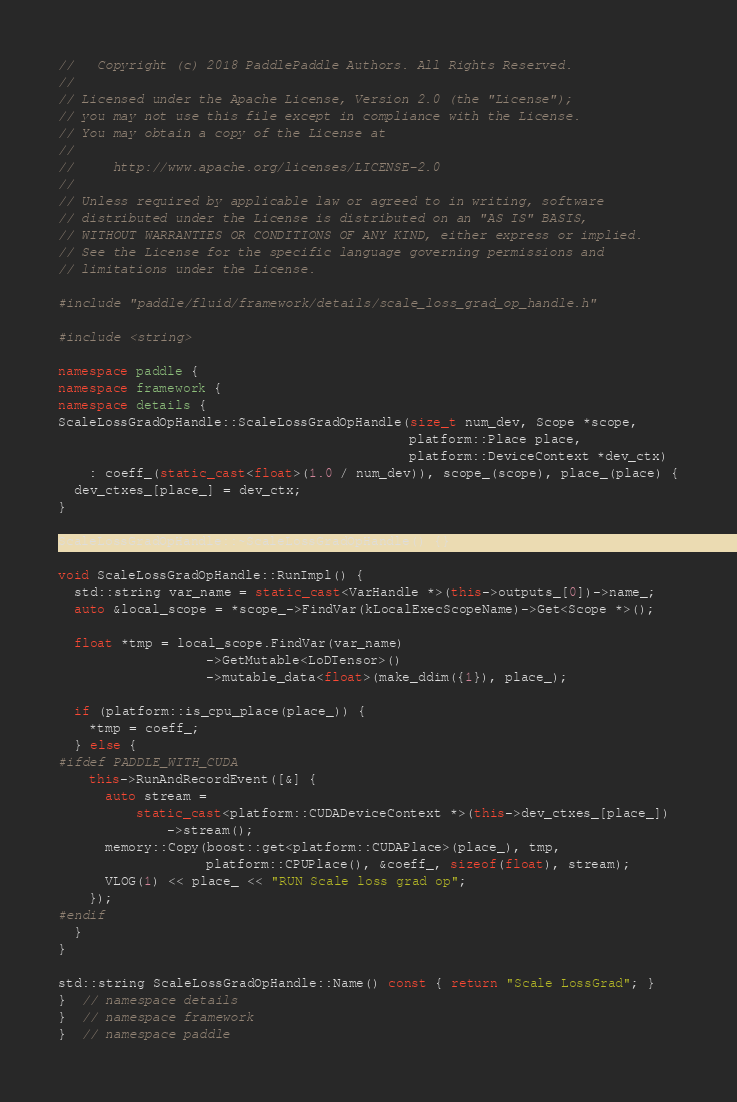<code> <loc_0><loc_0><loc_500><loc_500><_C++_>//   Copyright (c) 2018 PaddlePaddle Authors. All Rights Reserved.
//
// Licensed under the Apache License, Version 2.0 (the "License");
// you may not use this file except in compliance with the License.
// You may obtain a copy of the License at
//
//     http://www.apache.org/licenses/LICENSE-2.0
//
// Unless required by applicable law or agreed to in writing, software
// distributed under the License is distributed on an "AS IS" BASIS,
// WITHOUT WARRANTIES OR CONDITIONS OF ANY KIND, either express or implied.
// See the License for the specific language governing permissions and
// limitations under the License.

#include "paddle/fluid/framework/details/scale_loss_grad_op_handle.h"

#include <string>

namespace paddle {
namespace framework {
namespace details {
ScaleLossGradOpHandle::ScaleLossGradOpHandle(size_t num_dev, Scope *scope,
                                             platform::Place place,
                                             platform::DeviceContext *dev_ctx)
    : coeff_(static_cast<float>(1.0 / num_dev)), scope_(scope), place_(place) {
  dev_ctxes_[place_] = dev_ctx;
}

ScaleLossGradOpHandle::~ScaleLossGradOpHandle() {}

void ScaleLossGradOpHandle::RunImpl() {
  std::string var_name = static_cast<VarHandle *>(this->outputs_[0])->name_;
  auto &local_scope = *scope_->FindVar(kLocalExecScopeName)->Get<Scope *>();

  float *tmp = local_scope.FindVar(var_name)
                   ->GetMutable<LoDTensor>()
                   ->mutable_data<float>(make_ddim({1}), place_);

  if (platform::is_cpu_place(place_)) {
    *tmp = coeff_;
  } else {
#ifdef PADDLE_WITH_CUDA
    this->RunAndRecordEvent([&] {
      auto stream =
          static_cast<platform::CUDADeviceContext *>(this->dev_ctxes_[place_])
              ->stream();
      memory::Copy(boost::get<platform::CUDAPlace>(place_), tmp,
                   platform::CPUPlace(), &coeff_, sizeof(float), stream);
      VLOG(1) << place_ << "RUN Scale loss grad op";
    });
#endif
  }
}

std::string ScaleLossGradOpHandle::Name() const { return "Scale LossGrad"; }
}  // namespace details
}  // namespace framework
}  // namespace paddle
</code> 